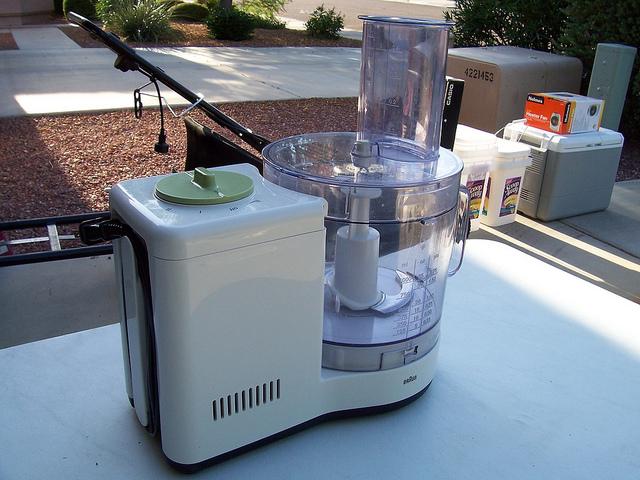Where is the lawn mower?
Keep it brief. Outside. Is this a blender?
Answer briefly. No. Is this a living room?
Write a very short answer. No. 